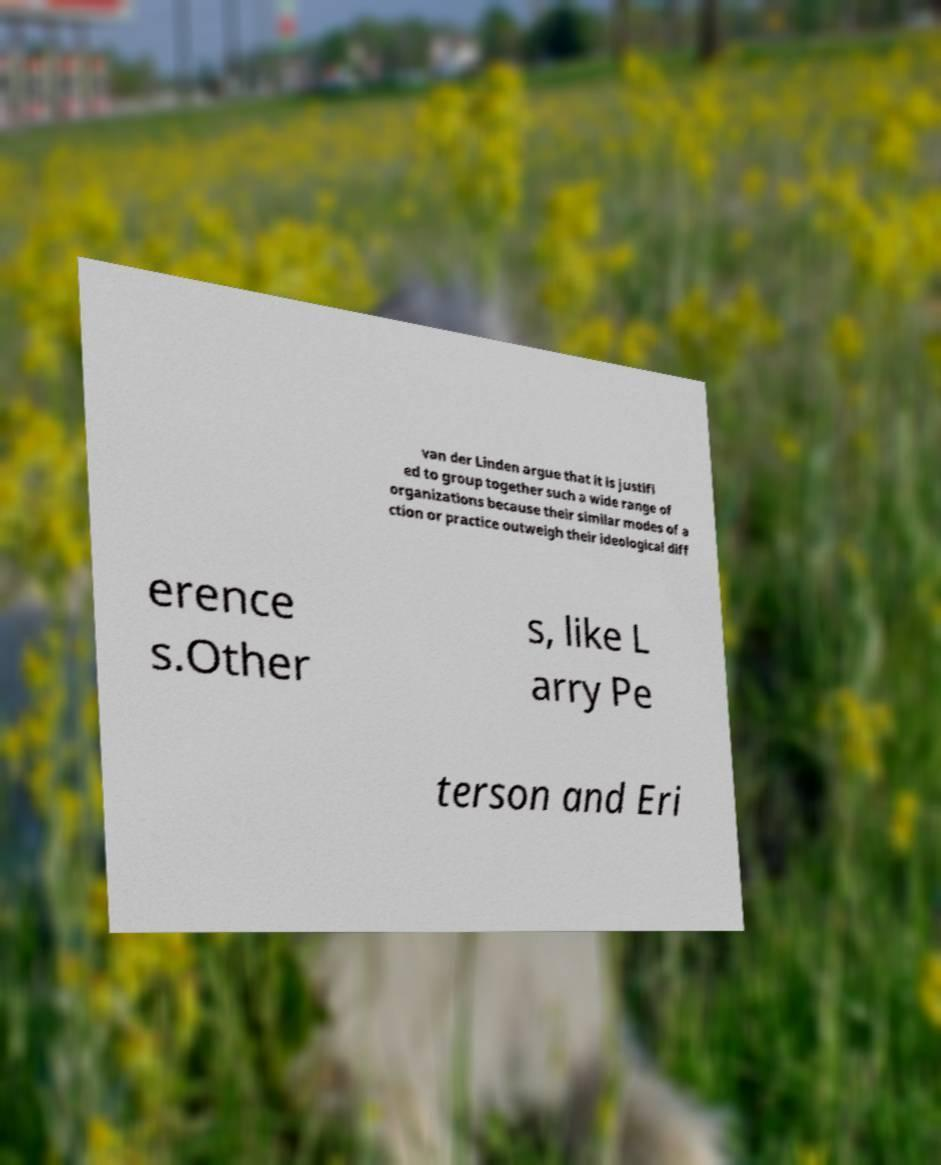What messages or text are displayed in this image? I need them in a readable, typed format. van der Linden argue that it is justifi ed to group together such a wide range of organizations because their similar modes of a ction or practice outweigh their ideological diff erence s.Other s, like L arry Pe terson and Eri 